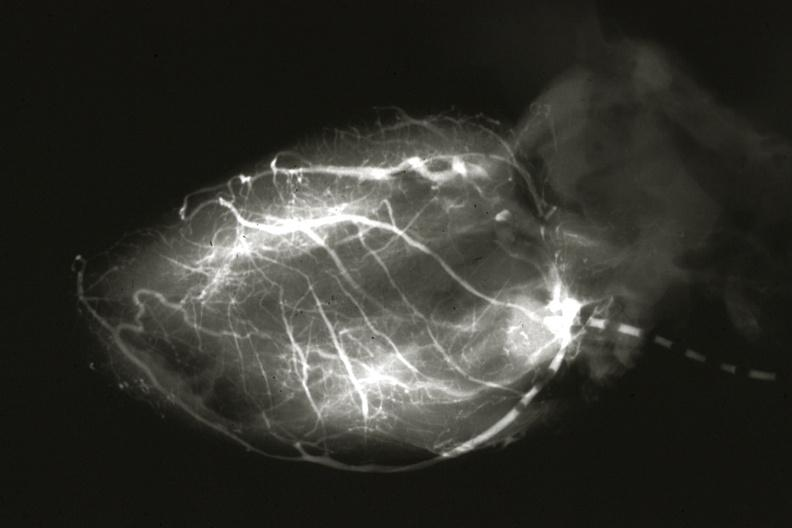does breast show angiogram postmortafter switch of left coronary to aorta?
Answer the question using a single word or phrase. No 